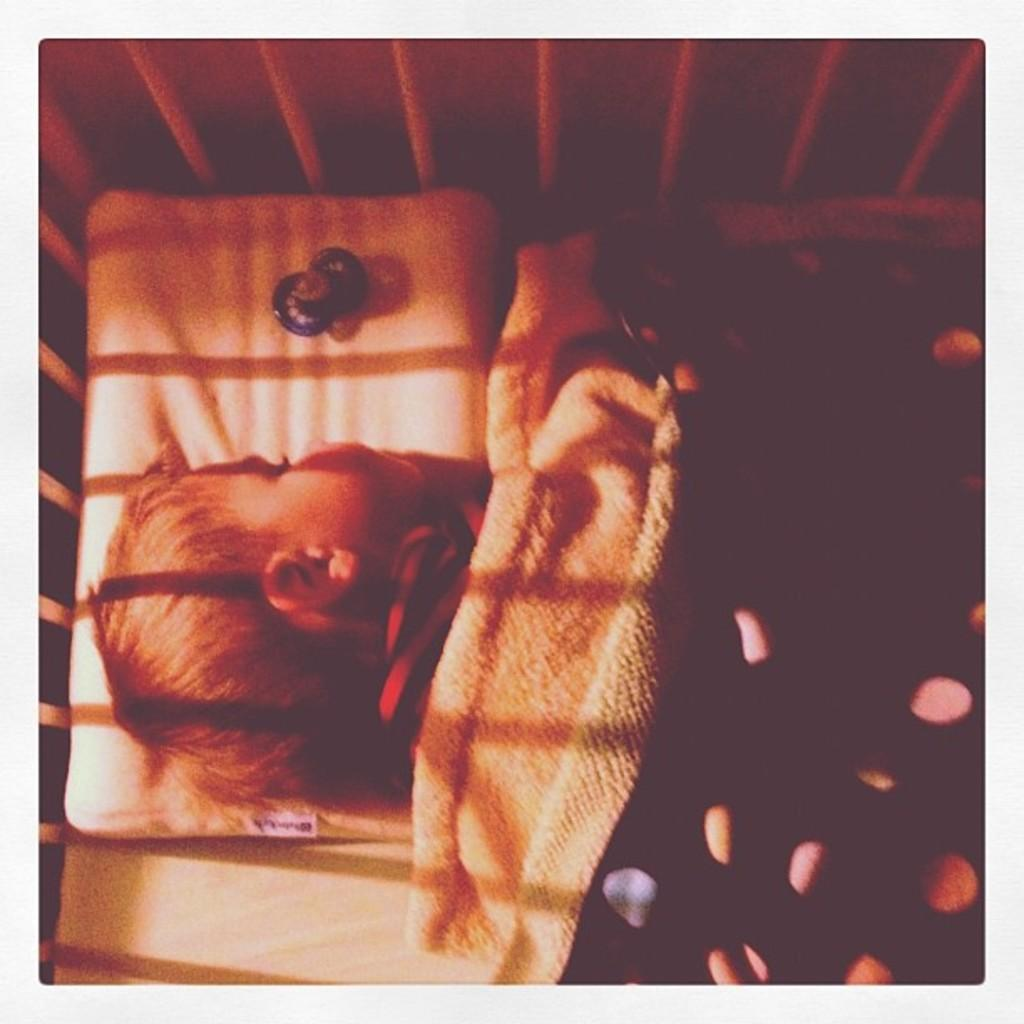What is the main subject of the image? There is a person sleeping in the image. Where is the person located in the image? The person is in the center of the image. What is covering the person in the image? There is a blanket on top of the person. What other object can be seen in the image? There is a white grill in the image. What type of substance is being discussed by the committee in the image? There is no committee or discussion of a substance present in the image; it features a person sleeping with a blanket and a white grill. 